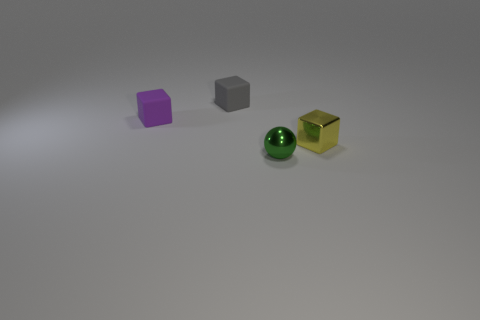What number of tiny green shiny objects are to the right of the purple cube?
Your answer should be compact. 1. Is there another purple matte thing of the same size as the purple rubber thing?
Make the answer very short. No. Are there any tiny rubber cubes of the same color as the small ball?
Ensure brevity in your answer.  No. Are there any other things that are the same size as the green ball?
Your answer should be compact. Yes. What number of rubber objects are the same color as the metallic sphere?
Ensure brevity in your answer.  0. There is a tiny shiny ball; does it have the same color as the small object on the right side of the tiny green metallic ball?
Provide a succinct answer. No. What number of things are tiny green matte cubes or small gray rubber blocks that are behind the shiny cube?
Offer a very short reply. 1. There is a shiny object on the right side of the metal thing on the left side of the tiny yellow shiny object; how big is it?
Offer a terse response. Small. Is the number of purple rubber things behind the purple object the same as the number of tiny purple blocks that are on the right side of the small green ball?
Your response must be concise. Yes. Is there a purple matte thing that is behind the small matte object that is to the left of the tiny gray rubber thing?
Your answer should be compact. No. 